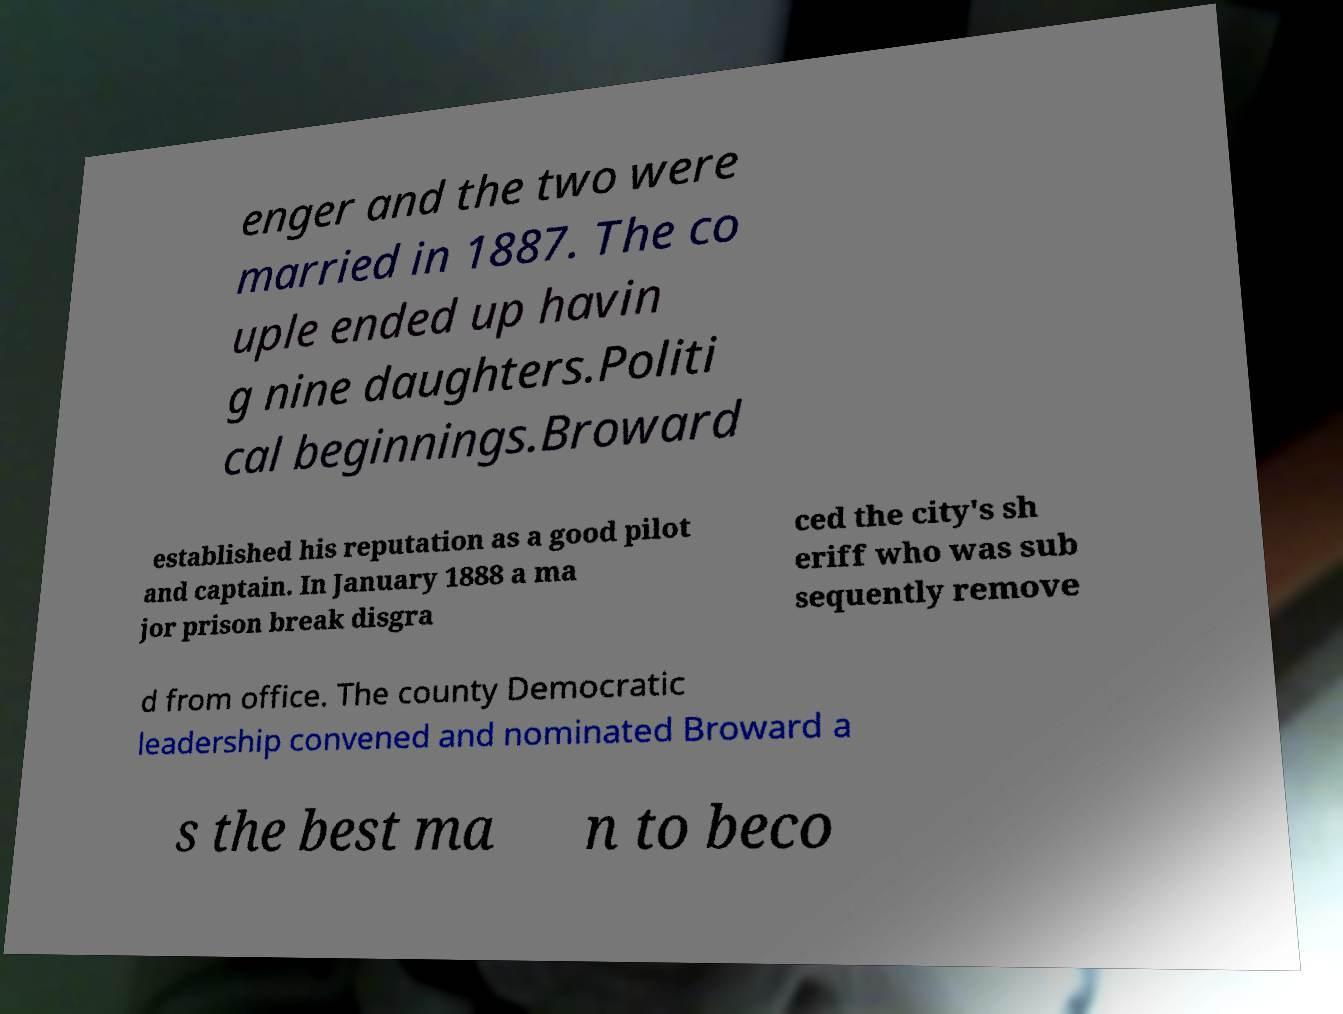I need the written content from this picture converted into text. Can you do that? enger and the two were married in 1887. The co uple ended up havin g nine daughters.Politi cal beginnings.Broward established his reputation as a good pilot and captain. In January 1888 a ma jor prison break disgra ced the city's sh eriff who was sub sequently remove d from office. The county Democratic leadership convened and nominated Broward a s the best ma n to beco 